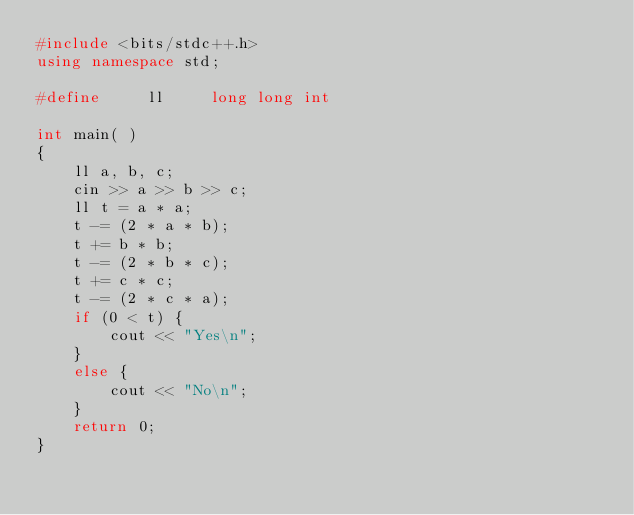Convert code to text. <code><loc_0><loc_0><loc_500><loc_500><_C++_>#include <bits/stdc++.h>
using namespace std;

#define     ll     long long int

int main( )
{
    ll a, b, c;
    cin >> a >> b >> c;
    ll t = a * a;
    t -= (2 * a * b);
    t += b * b;
    t -= (2 * b * c);
    t += c * c;
    t -= (2 * c * a);
    if (0 < t) {
        cout << "Yes\n";
    }
    else {
        cout << "No\n";
    }
    return 0;
}
</code> 